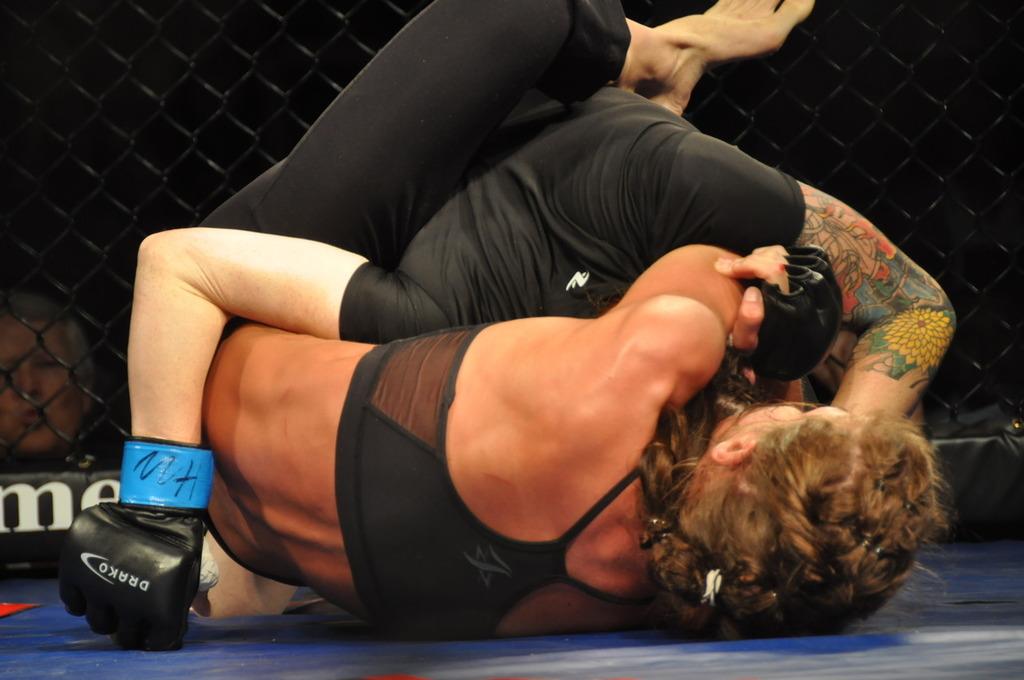What is the letter on the black sign in the background?
Ensure brevity in your answer.  M. What gloves are those?
Your response must be concise. Drako. 